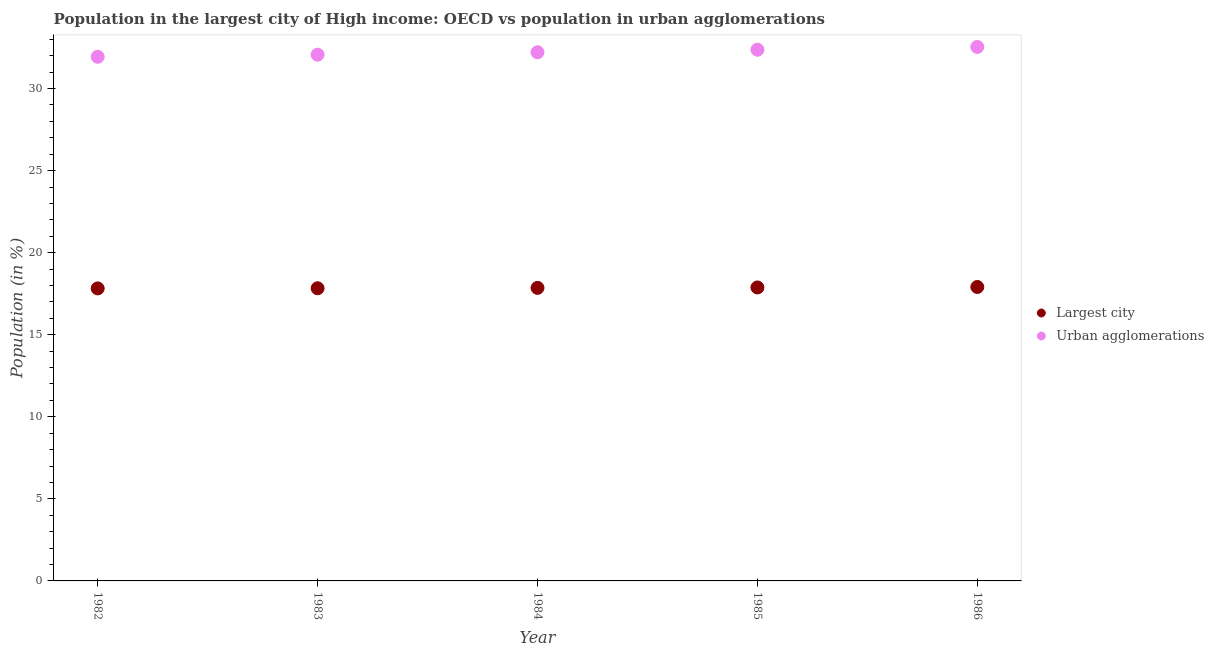How many different coloured dotlines are there?
Your answer should be very brief. 2. Is the number of dotlines equal to the number of legend labels?
Give a very brief answer. Yes. What is the population in urban agglomerations in 1982?
Offer a terse response. 31.93. Across all years, what is the maximum population in urban agglomerations?
Keep it short and to the point. 32.53. Across all years, what is the minimum population in the largest city?
Your answer should be compact. 17.82. In which year was the population in the largest city minimum?
Your answer should be compact. 1982. What is the total population in urban agglomerations in the graph?
Provide a succinct answer. 161.11. What is the difference between the population in the largest city in 1982 and that in 1984?
Your response must be concise. -0.03. What is the difference between the population in the largest city in 1983 and the population in urban agglomerations in 1984?
Offer a terse response. -14.38. What is the average population in the largest city per year?
Offer a very short reply. 17.86. In the year 1986, what is the difference between the population in urban agglomerations and population in the largest city?
Provide a short and direct response. 14.62. What is the ratio of the population in urban agglomerations in 1982 to that in 1983?
Provide a short and direct response. 1. Is the population in the largest city in 1983 less than that in 1985?
Offer a very short reply. Yes. What is the difference between the highest and the second highest population in the largest city?
Offer a very short reply. 0.03. What is the difference between the highest and the lowest population in the largest city?
Your answer should be very brief. 0.09. In how many years, is the population in the largest city greater than the average population in the largest city taken over all years?
Keep it short and to the point. 2. Is the population in urban agglomerations strictly less than the population in the largest city over the years?
Keep it short and to the point. No. How many dotlines are there?
Provide a short and direct response. 2. How many years are there in the graph?
Keep it short and to the point. 5. Are the values on the major ticks of Y-axis written in scientific E-notation?
Give a very brief answer. No. Does the graph contain any zero values?
Make the answer very short. No. What is the title of the graph?
Give a very brief answer. Population in the largest city of High income: OECD vs population in urban agglomerations. What is the label or title of the X-axis?
Ensure brevity in your answer.  Year. What is the label or title of the Y-axis?
Your answer should be compact. Population (in %). What is the Population (in %) in Largest city in 1982?
Provide a short and direct response. 17.82. What is the Population (in %) of Urban agglomerations in 1982?
Provide a short and direct response. 31.93. What is the Population (in %) of Largest city in 1983?
Your answer should be compact. 17.83. What is the Population (in %) of Urban agglomerations in 1983?
Offer a very short reply. 32.06. What is the Population (in %) in Largest city in 1984?
Your answer should be compact. 17.85. What is the Population (in %) of Urban agglomerations in 1984?
Your response must be concise. 32.21. What is the Population (in %) of Largest city in 1985?
Provide a short and direct response. 17.88. What is the Population (in %) in Urban agglomerations in 1985?
Keep it short and to the point. 32.36. What is the Population (in %) in Largest city in 1986?
Make the answer very short. 17.91. What is the Population (in %) in Urban agglomerations in 1986?
Make the answer very short. 32.53. Across all years, what is the maximum Population (in %) in Largest city?
Your response must be concise. 17.91. Across all years, what is the maximum Population (in %) in Urban agglomerations?
Provide a short and direct response. 32.53. Across all years, what is the minimum Population (in %) in Largest city?
Ensure brevity in your answer.  17.82. Across all years, what is the minimum Population (in %) in Urban agglomerations?
Keep it short and to the point. 31.93. What is the total Population (in %) in Largest city in the graph?
Your answer should be compact. 89.3. What is the total Population (in %) of Urban agglomerations in the graph?
Ensure brevity in your answer.  161.11. What is the difference between the Population (in %) of Largest city in 1982 and that in 1983?
Make the answer very short. -0.01. What is the difference between the Population (in %) in Urban agglomerations in 1982 and that in 1983?
Provide a short and direct response. -0.13. What is the difference between the Population (in %) in Largest city in 1982 and that in 1984?
Offer a very short reply. -0.03. What is the difference between the Population (in %) of Urban agglomerations in 1982 and that in 1984?
Make the answer very short. -0.28. What is the difference between the Population (in %) of Largest city in 1982 and that in 1985?
Provide a succinct answer. -0.06. What is the difference between the Population (in %) of Urban agglomerations in 1982 and that in 1985?
Provide a short and direct response. -0.43. What is the difference between the Population (in %) of Largest city in 1982 and that in 1986?
Make the answer very short. -0.09. What is the difference between the Population (in %) of Urban agglomerations in 1982 and that in 1986?
Ensure brevity in your answer.  -0.6. What is the difference between the Population (in %) in Largest city in 1983 and that in 1984?
Provide a succinct answer. -0.02. What is the difference between the Population (in %) of Urban agglomerations in 1983 and that in 1984?
Keep it short and to the point. -0.15. What is the difference between the Population (in %) of Largest city in 1983 and that in 1985?
Provide a succinct answer. -0.05. What is the difference between the Population (in %) of Urban agglomerations in 1983 and that in 1985?
Your answer should be compact. -0.3. What is the difference between the Population (in %) of Largest city in 1983 and that in 1986?
Offer a terse response. -0.08. What is the difference between the Population (in %) in Urban agglomerations in 1983 and that in 1986?
Keep it short and to the point. -0.47. What is the difference between the Population (in %) of Largest city in 1984 and that in 1985?
Ensure brevity in your answer.  -0.03. What is the difference between the Population (in %) of Urban agglomerations in 1984 and that in 1985?
Provide a short and direct response. -0.15. What is the difference between the Population (in %) in Largest city in 1984 and that in 1986?
Ensure brevity in your answer.  -0.06. What is the difference between the Population (in %) of Urban agglomerations in 1984 and that in 1986?
Provide a short and direct response. -0.32. What is the difference between the Population (in %) in Largest city in 1985 and that in 1986?
Offer a very short reply. -0.03. What is the difference between the Population (in %) in Urban agglomerations in 1985 and that in 1986?
Offer a terse response. -0.17. What is the difference between the Population (in %) of Largest city in 1982 and the Population (in %) of Urban agglomerations in 1983?
Make the answer very short. -14.24. What is the difference between the Population (in %) of Largest city in 1982 and the Population (in %) of Urban agglomerations in 1984?
Offer a terse response. -14.39. What is the difference between the Population (in %) in Largest city in 1982 and the Population (in %) in Urban agglomerations in 1985?
Ensure brevity in your answer.  -14.54. What is the difference between the Population (in %) in Largest city in 1982 and the Population (in %) in Urban agglomerations in 1986?
Your answer should be very brief. -14.71. What is the difference between the Population (in %) in Largest city in 1983 and the Population (in %) in Urban agglomerations in 1984?
Keep it short and to the point. -14.38. What is the difference between the Population (in %) in Largest city in 1983 and the Population (in %) in Urban agglomerations in 1985?
Your response must be concise. -14.53. What is the difference between the Population (in %) of Largest city in 1983 and the Population (in %) of Urban agglomerations in 1986?
Your answer should be compact. -14.7. What is the difference between the Population (in %) in Largest city in 1984 and the Population (in %) in Urban agglomerations in 1985?
Provide a short and direct response. -14.51. What is the difference between the Population (in %) in Largest city in 1984 and the Population (in %) in Urban agglomerations in 1986?
Ensure brevity in your answer.  -14.68. What is the difference between the Population (in %) in Largest city in 1985 and the Population (in %) in Urban agglomerations in 1986?
Provide a succinct answer. -14.65. What is the average Population (in %) in Largest city per year?
Your answer should be compact. 17.86. What is the average Population (in %) in Urban agglomerations per year?
Make the answer very short. 32.22. In the year 1982, what is the difference between the Population (in %) in Largest city and Population (in %) in Urban agglomerations?
Offer a very short reply. -14.11. In the year 1983, what is the difference between the Population (in %) in Largest city and Population (in %) in Urban agglomerations?
Give a very brief answer. -14.23. In the year 1984, what is the difference between the Population (in %) in Largest city and Population (in %) in Urban agglomerations?
Your answer should be very brief. -14.36. In the year 1985, what is the difference between the Population (in %) of Largest city and Population (in %) of Urban agglomerations?
Give a very brief answer. -14.48. In the year 1986, what is the difference between the Population (in %) in Largest city and Population (in %) in Urban agglomerations?
Your answer should be compact. -14.62. What is the ratio of the Population (in %) in Largest city in 1982 to that in 1984?
Your answer should be very brief. 1. What is the ratio of the Population (in %) in Urban agglomerations in 1982 to that in 1984?
Ensure brevity in your answer.  0.99. What is the ratio of the Population (in %) in Largest city in 1982 to that in 1985?
Your answer should be very brief. 1. What is the ratio of the Population (in %) in Urban agglomerations in 1982 to that in 1985?
Make the answer very short. 0.99. What is the ratio of the Population (in %) of Largest city in 1982 to that in 1986?
Give a very brief answer. 1. What is the ratio of the Population (in %) in Urban agglomerations in 1982 to that in 1986?
Offer a very short reply. 0.98. What is the ratio of the Population (in %) of Largest city in 1983 to that in 1985?
Offer a very short reply. 1. What is the ratio of the Population (in %) of Urban agglomerations in 1983 to that in 1986?
Provide a short and direct response. 0.99. What is the ratio of the Population (in %) in Largest city in 1984 to that in 1986?
Offer a very short reply. 1. What is the ratio of the Population (in %) of Largest city in 1985 to that in 1986?
Give a very brief answer. 1. What is the difference between the highest and the second highest Population (in %) of Largest city?
Offer a very short reply. 0.03. What is the difference between the highest and the second highest Population (in %) of Urban agglomerations?
Keep it short and to the point. 0.17. What is the difference between the highest and the lowest Population (in %) in Largest city?
Provide a short and direct response. 0.09. What is the difference between the highest and the lowest Population (in %) in Urban agglomerations?
Give a very brief answer. 0.6. 